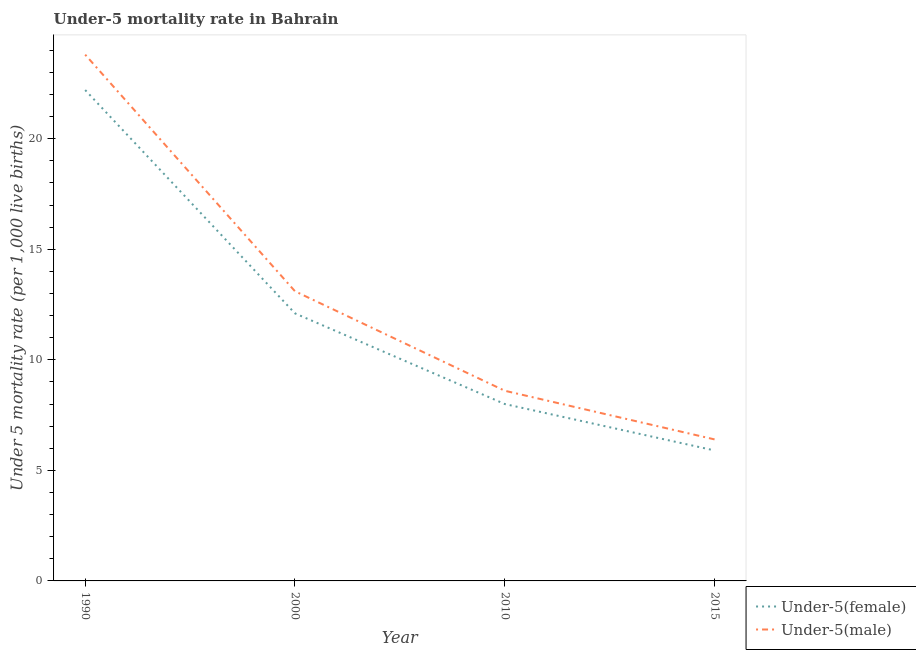What is the under-5 female mortality rate in 2010?
Your answer should be compact. 8. Across all years, what is the minimum under-5 male mortality rate?
Your response must be concise. 6.4. In which year was the under-5 male mortality rate minimum?
Your response must be concise. 2015. What is the total under-5 female mortality rate in the graph?
Offer a terse response. 48.2. What is the difference between the under-5 male mortality rate in 1990 and that in 2000?
Keep it short and to the point. 10.7. What is the difference between the under-5 female mortality rate in 2000 and the under-5 male mortality rate in 1990?
Keep it short and to the point. -11.7. What is the average under-5 male mortality rate per year?
Your answer should be compact. 12.97. In the year 1990, what is the difference between the under-5 female mortality rate and under-5 male mortality rate?
Your response must be concise. -1.6. What is the ratio of the under-5 male mortality rate in 1990 to that in 2015?
Your answer should be compact. 3.72. Is the under-5 male mortality rate in 2000 less than that in 2010?
Make the answer very short. No. What is the difference between the highest and the second highest under-5 male mortality rate?
Ensure brevity in your answer.  10.7. What is the difference between the highest and the lowest under-5 male mortality rate?
Ensure brevity in your answer.  17.4. Is the sum of the under-5 female mortality rate in 2000 and 2010 greater than the maximum under-5 male mortality rate across all years?
Provide a succinct answer. No. Does the under-5 male mortality rate monotonically increase over the years?
Your response must be concise. No. Is the under-5 male mortality rate strictly greater than the under-5 female mortality rate over the years?
Give a very brief answer. Yes. How many lines are there?
Provide a succinct answer. 2. How many years are there in the graph?
Your answer should be very brief. 4. Does the graph contain any zero values?
Your response must be concise. No. Does the graph contain grids?
Make the answer very short. No. Where does the legend appear in the graph?
Offer a terse response. Bottom right. How many legend labels are there?
Ensure brevity in your answer.  2. What is the title of the graph?
Your answer should be compact. Under-5 mortality rate in Bahrain. What is the label or title of the Y-axis?
Offer a very short reply. Under 5 mortality rate (per 1,0 live births). What is the Under 5 mortality rate (per 1,000 live births) of Under-5(male) in 1990?
Provide a short and direct response. 23.8. What is the Under 5 mortality rate (per 1,000 live births) of Under-5(male) in 2000?
Make the answer very short. 13.1. What is the Under 5 mortality rate (per 1,000 live births) of Under-5(female) in 2010?
Your answer should be very brief. 8. What is the Under 5 mortality rate (per 1,000 live births) in Under-5(male) in 2010?
Your response must be concise. 8.6. What is the Under 5 mortality rate (per 1,000 live births) of Under-5(male) in 2015?
Your response must be concise. 6.4. Across all years, what is the maximum Under 5 mortality rate (per 1,000 live births) of Under-5(female)?
Offer a very short reply. 22.2. Across all years, what is the maximum Under 5 mortality rate (per 1,000 live births) of Under-5(male)?
Your answer should be very brief. 23.8. Across all years, what is the minimum Under 5 mortality rate (per 1,000 live births) in Under-5(female)?
Ensure brevity in your answer.  5.9. What is the total Under 5 mortality rate (per 1,000 live births) in Under-5(female) in the graph?
Make the answer very short. 48.2. What is the total Under 5 mortality rate (per 1,000 live births) of Under-5(male) in the graph?
Your response must be concise. 51.9. What is the difference between the Under 5 mortality rate (per 1,000 live births) in Under-5(male) in 1990 and that in 2015?
Your response must be concise. 17.4. What is the difference between the Under 5 mortality rate (per 1,000 live births) of Under-5(female) in 2000 and that in 2010?
Offer a terse response. 4.1. What is the difference between the Under 5 mortality rate (per 1,000 live births) of Under-5(male) in 2000 and that in 2015?
Provide a succinct answer. 6.7. What is the difference between the Under 5 mortality rate (per 1,000 live births) in Under-5(female) in 2010 and that in 2015?
Provide a succinct answer. 2.1. What is the difference between the Under 5 mortality rate (per 1,000 live births) of Under-5(male) in 2010 and that in 2015?
Offer a very short reply. 2.2. What is the difference between the Under 5 mortality rate (per 1,000 live births) in Under-5(female) in 1990 and the Under 5 mortality rate (per 1,000 live births) in Under-5(male) in 2000?
Provide a short and direct response. 9.1. What is the difference between the Under 5 mortality rate (per 1,000 live births) in Under-5(female) in 2000 and the Under 5 mortality rate (per 1,000 live births) in Under-5(male) in 2010?
Keep it short and to the point. 3.5. What is the average Under 5 mortality rate (per 1,000 live births) of Under-5(female) per year?
Ensure brevity in your answer.  12.05. What is the average Under 5 mortality rate (per 1,000 live births) in Under-5(male) per year?
Provide a short and direct response. 12.97. In the year 1990, what is the difference between the Under 5 mortality rate (per 1,000 live births) of Under-5(female) and Under 5 mortality rate (per 1,000 live births) of Under-5(male)?
Your response must be concise. -1.6. In the year 2000, what is the difference between the Under 5 mortality rate (per 1,000 live births) of Under-5(female) and Under 5 mortality rate (per 1,000 live births) of Under-5(male)?
Your answer should be very brief. -1. In the year 2010, what is the difference between the Under 5 mortality rate (per 1,000 live births) of Under-5(female) and Under 5 mortality rate (per 1,000 live births) of Under-5(male)?
Provide a succinct answer. -0.6. What is the ratio of the Under 5 mortality rate (per 1,000 live births) in Under-5(female) in 1990 to that in 2000?
Your answer should be compact. 1.83. What is the ratio of the Under 5 mortality rate (per 1,000 live births) of Under-5(male) in 1990 to that in 2000?
Give a very brief answer. 1.82. What is the ratio of the Under 5 mortality rate (per 1,000 live births) of Under-5(female) in 1990 to that in 2010?
Make the answer very short. 2.77. What is the ratio of the Under 5 mortality rate (per 1,000 live births) in Under-5(male) in 1990 to that in 2010?
Your answer should be very brief. 2.77. What is the ratio of the Under 5 mortality rate (per 1,000 live births) of Under-5(female) in 1990 to that in 2015?
Ensure brevity in your answer.  3.76. What is the ratio of the Under 5 mortality rate (per 1,000 live births) of Under-5(male) in 1990 to that in 2015?
Make the answer very short. 3.72. What is the ratio of the Under 5 mortality rate (per 1,000 live births) of Under-5(female) in 2000 to that in 2010?
Offer a very short reply. 1.51. What is the ratio of the Under 5 mortality rate (per 1,000 live births) of Under-5(male) in 2000 to that in 2010?
Keep it short and to the point. 1.52. What is the ratio of the Under 5 mortality rate (per 1,000 live births) of Under-5(female) in 2000 to that in 2015?
Your answer should be very brief. 2.05. What is the ratio of the Under 5 mortality rate (per 1,000 live births) of Under-5(male) in 2000 to that in 2015?
Provide a short and direct response. 2.05. What is the ratio of the Under 5 mortality rate (per 1,000 live births) of Under-5(female) in 2010 to that in 2015?
Offer a very short reply. 1.36. What is the ratio of the Under 5 mortality rate (per 1,000 live births) in Under-5(male) in 2010 to that in 2015?
Offer a very short reply. 1.34. What is the difference between the highest and the lowest Under 5 mortality rate (per 1,000 live births) in Under-5(female)?
Provide a succinct answer. 16.3. What is the difference between the highest and the lowest Under 5 mortality rate (per 1,000 live births) in Under-5(male)?
Offer a very short reply. 17.4. 